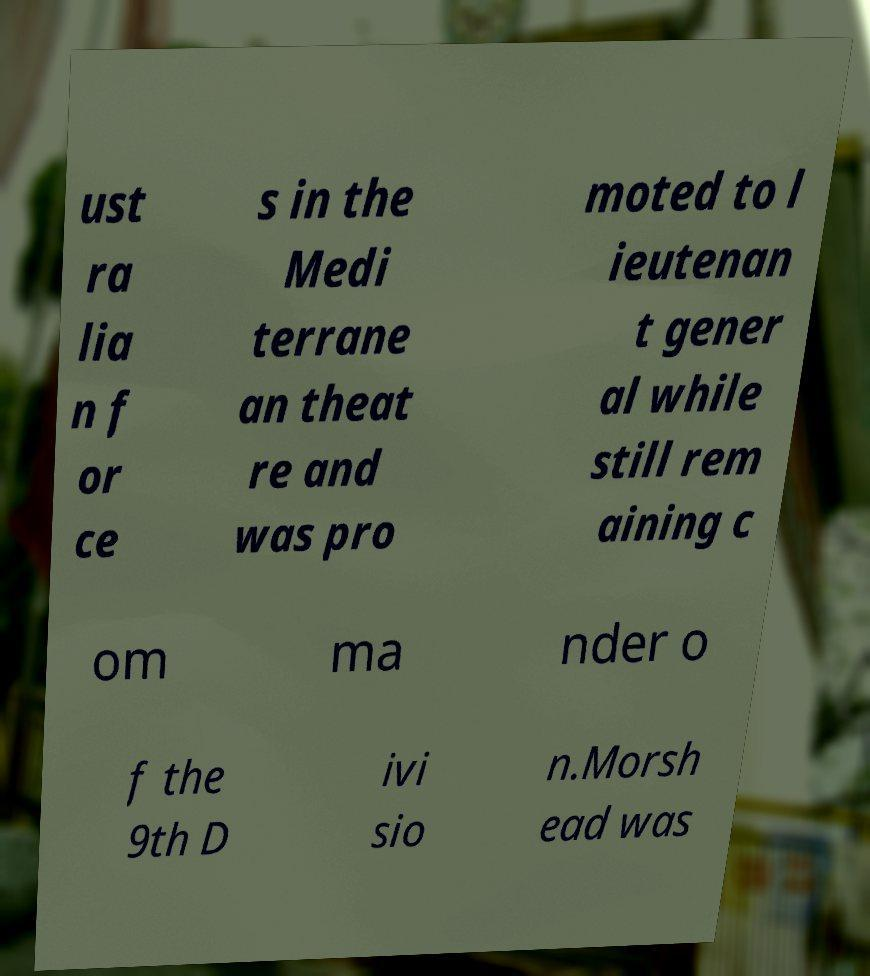Could you assist in decoding the text presented in this image and type it out clearly? ust ra lia n f or ce s in the Medi terrane an theat re and was pro moted to l ieutenan t gener al while still rem aining c om ma nder o f the 9th D ivi sio n.Morsh ead was 